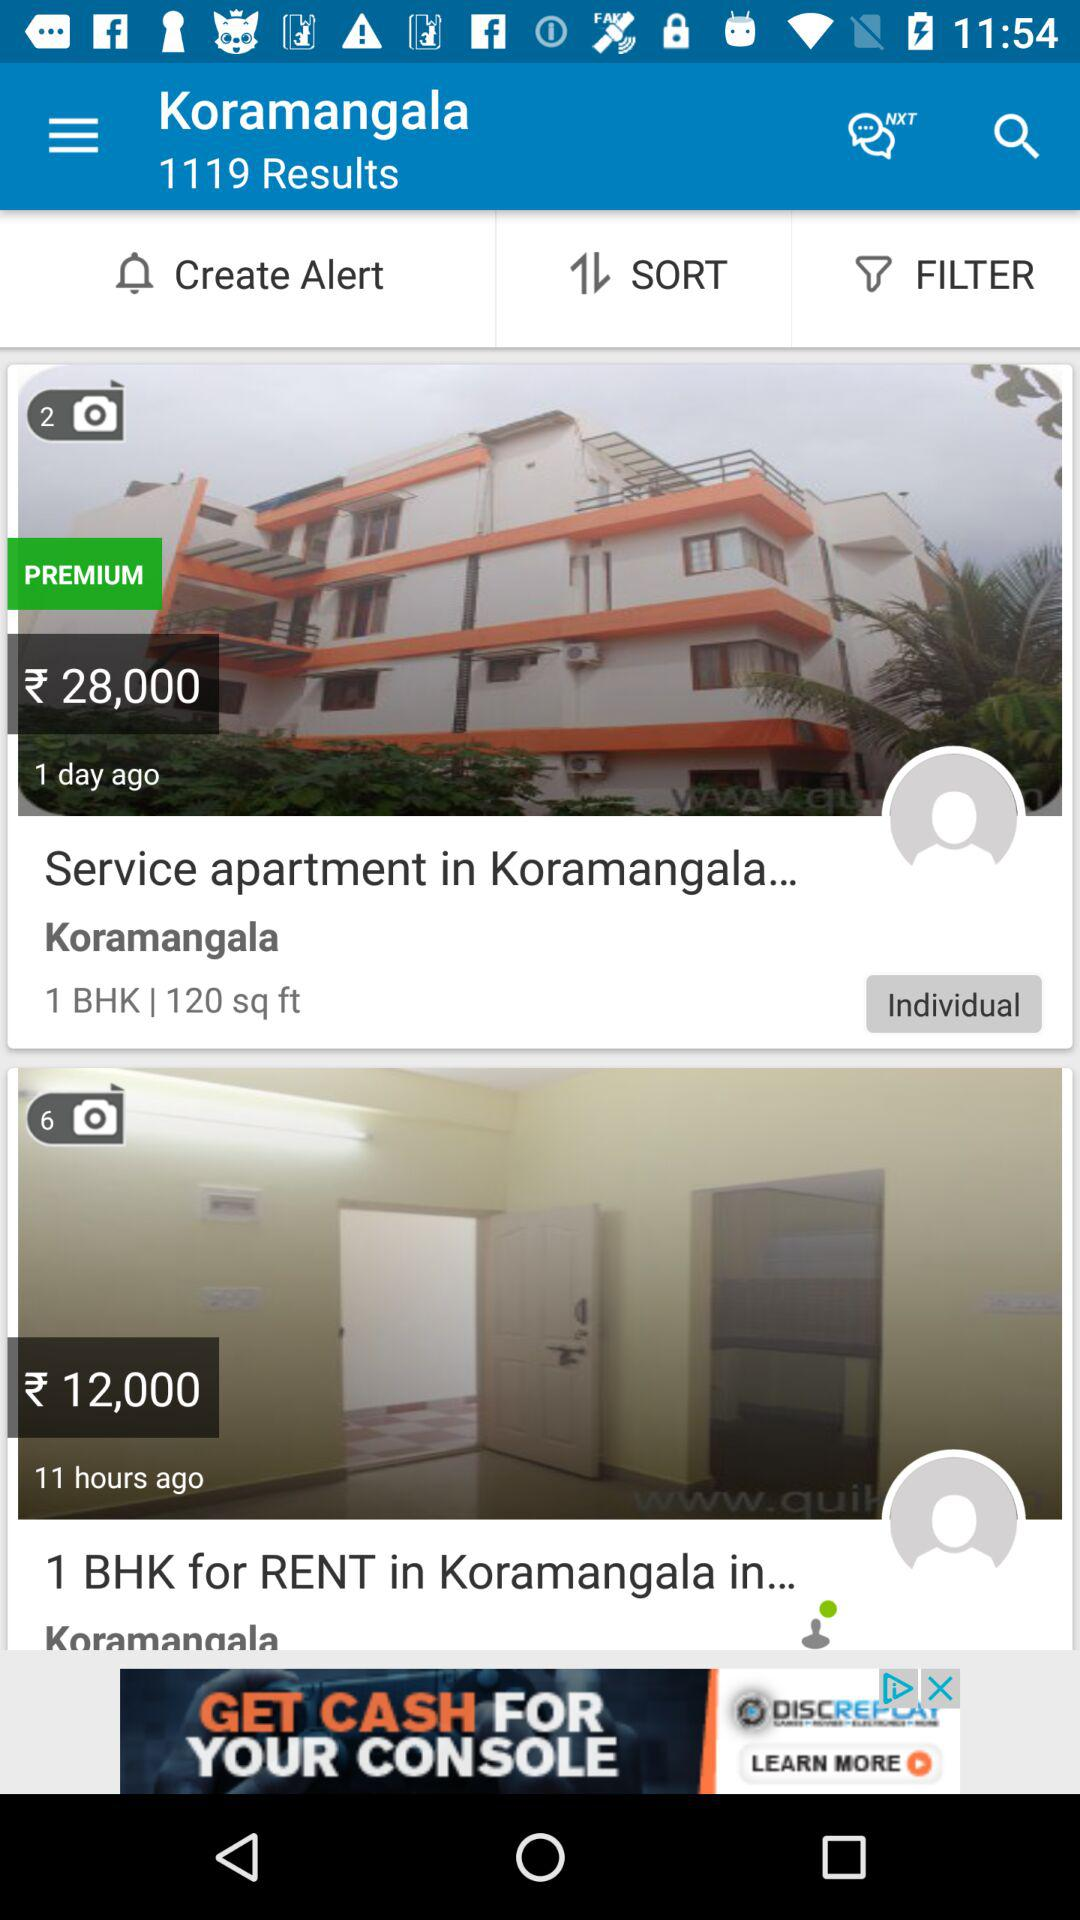How many results in total are there for Koramangala? There are 1119 results for Koramangala. 